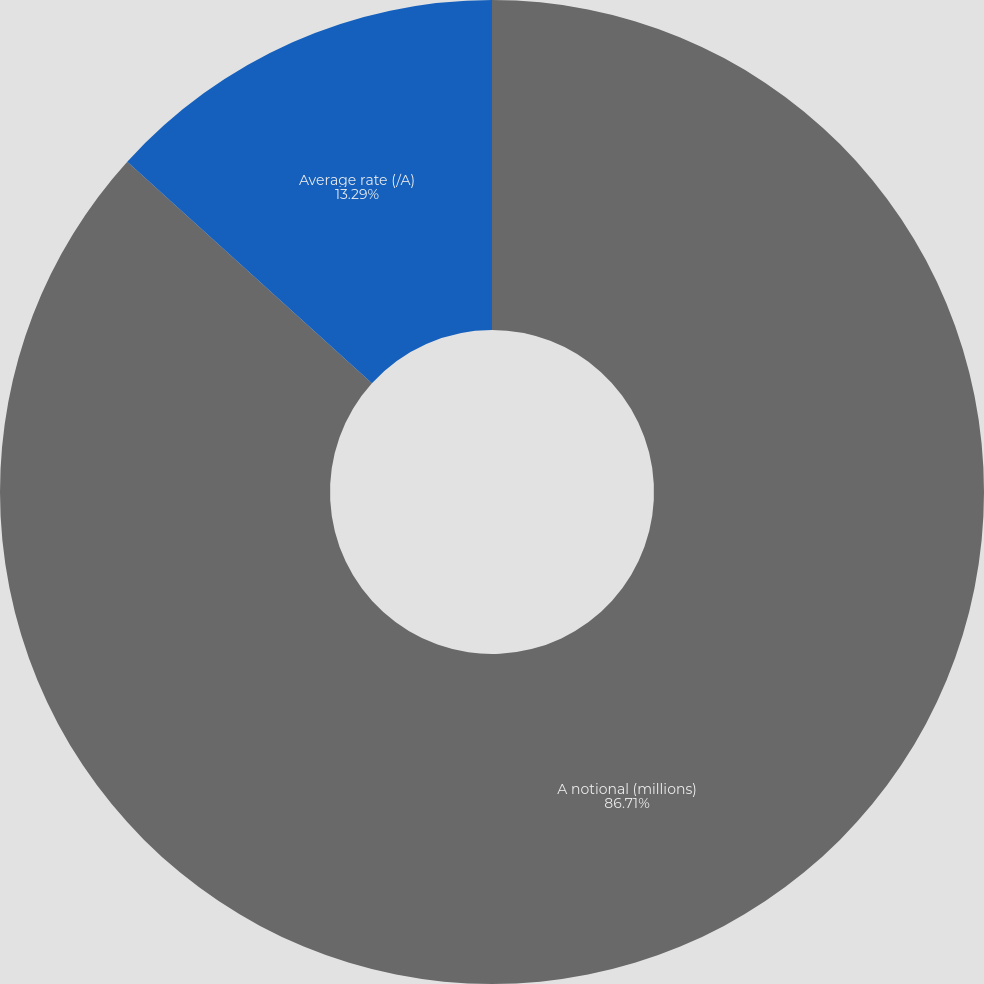Convert chart to OTSL. <chart><loc_0><loc_0><loc_500><loc_500><pie_chart><fcel>A notional (millions)<fcel>Average rate (/A)<nl><fcel>86.71%<fcel>13.29%<nl></chart> 